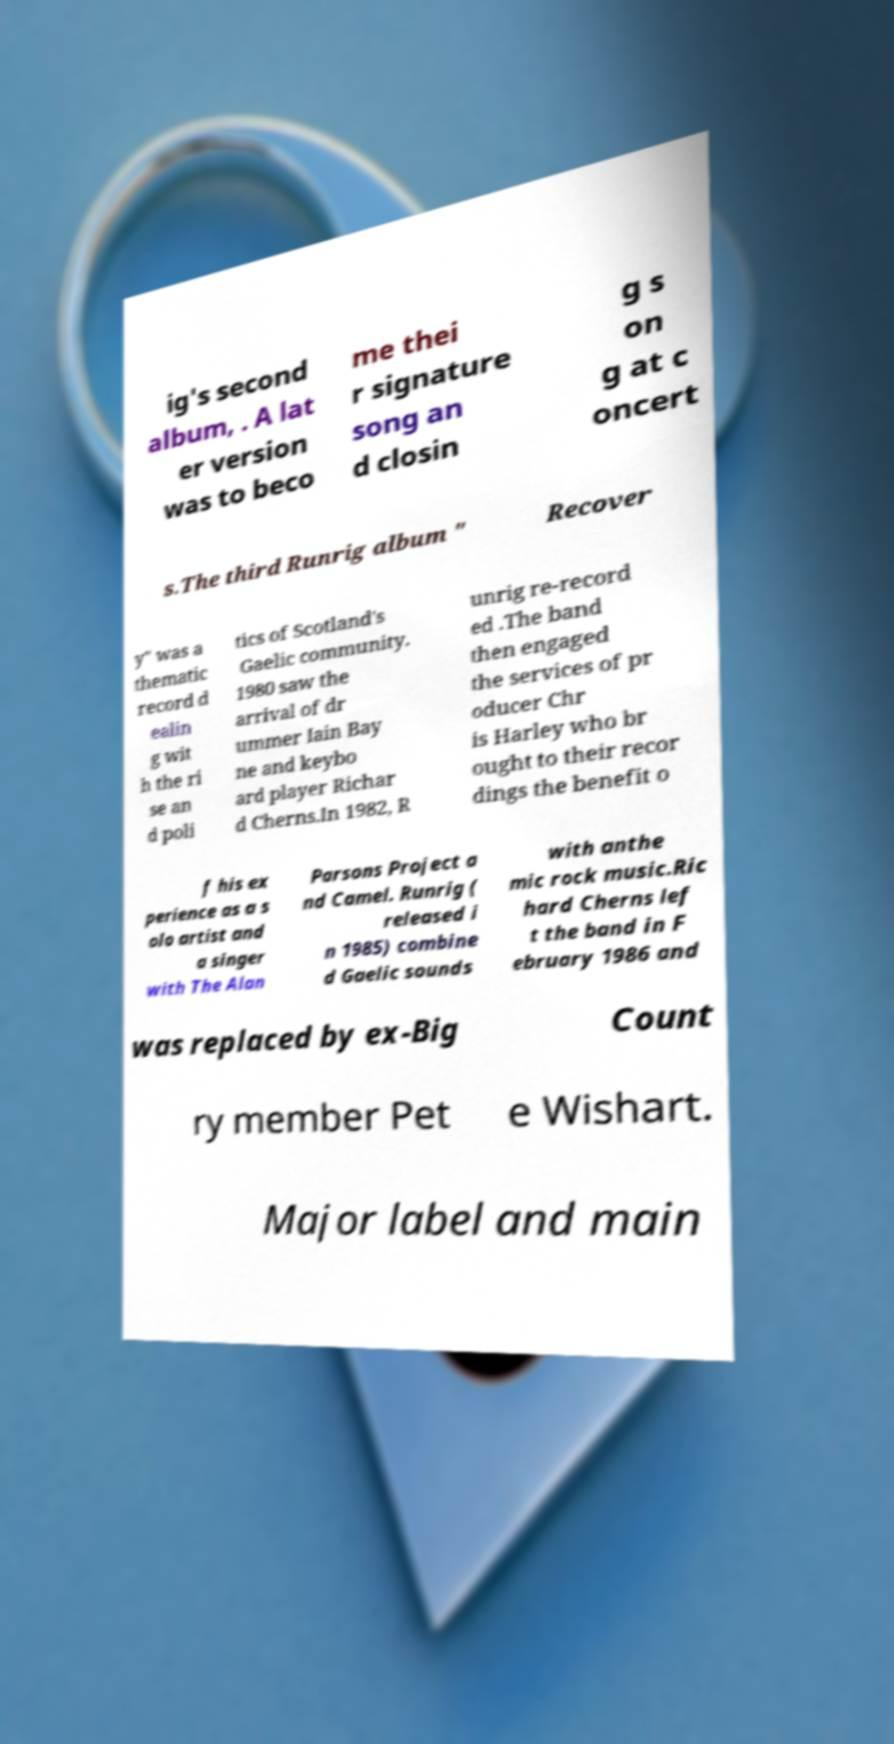Can you read and provide the text displayed in the image?This photo seems to have some interesting text. Can you extract and type it out for me? ig's second album, . A lat er version was to beco me thei r signature song an d closin g s on g at c oncert s.The third Runrig album " Recover y" was a thematic record d ealin g wit h the ri se an d poli tics of Scotland's Gaelic community. 1980 saw the arrival of dr ummer Iain Bay ne and keybo ard player Richar d Cherns.In 1982, R unrig re-record ed .The band then engaged the services of pr oducer Chr is Harley who br ought to their recor dings the benefit o f his ex perience as a s olo artist and a singer with The Alan Parsons Project a nd Camel. Runrig ( released i n 1985) combine d Gaelic sounds with anthe mic rock music.Ric hard Cherns lef t the band in F ebruary 1986 and was replaced by ex-Big Count ry member Pet e Wishart. Major label and main 